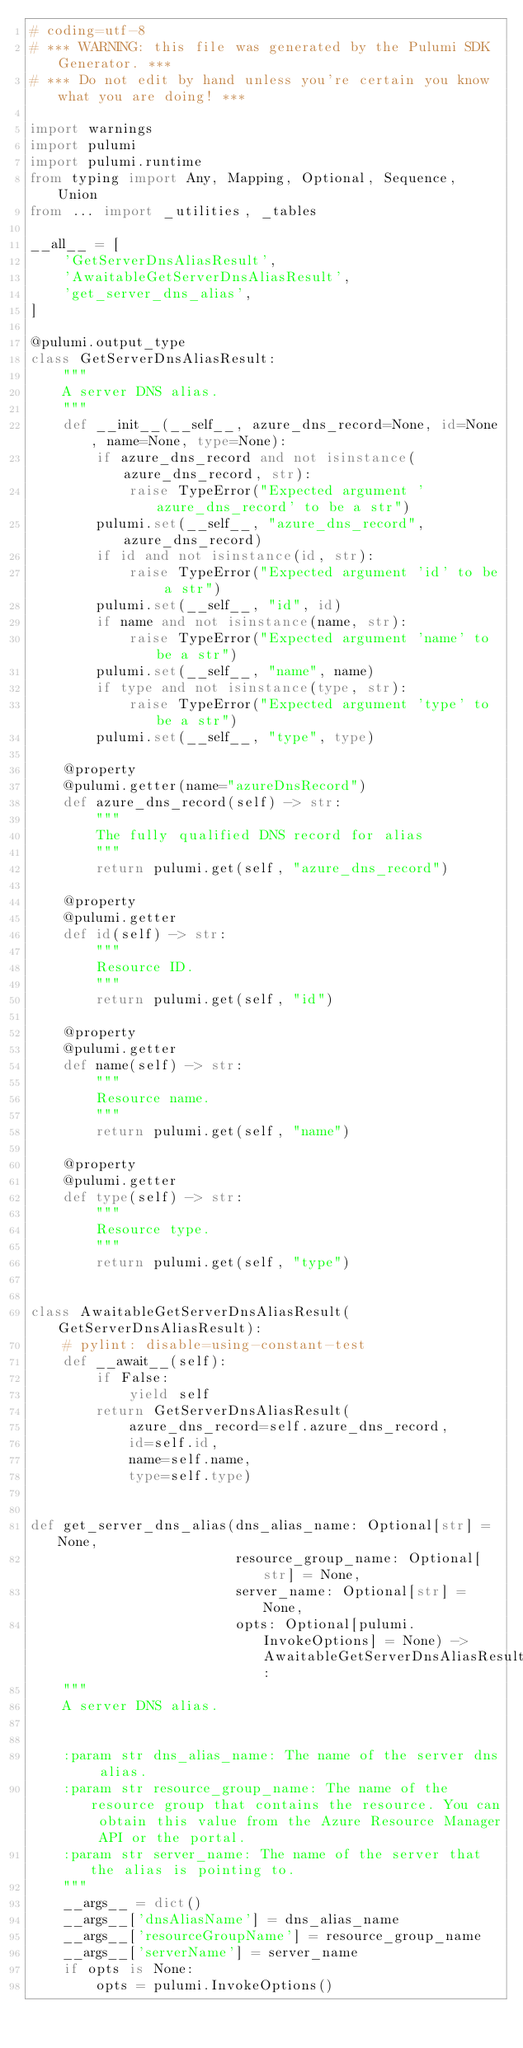Convert code to text. <code><loc_0><loc_0><loc_500><loc_500><_Python_># coding=utf-8
# *** WARNING: this file was generated by the Pulumi SDK Generator. ***
# *** Do not edit by hand unless you're certain you know what you are doing! ***

import warnings
import pulumi
import pulumi.runtime
from typing import Any, Mapping, Optional, Sequence, Union
from ... import _utilities, _tables

__all__ = [
    'GetServerDnsAliasResult',
    'AwaitableGetServerDnsAliasResult',
    'get_server_dns_alias',
]

@pulumi.output_type
class GetServerDnsAliasResult:
    """
    A server DNS alias.
    """
    def __init__(__self__, azure_dns_record=None, id=None, name=None, type=None):
        if azure_dns_record and not isinstance(azure_dns_record, str):
            raise TypeError("Expected argument 'azure_dns_record' to be a str")
        pulumi.set(__self__, "azure_dns_record", azure_dns_record)
        if id and not isinstance(id, str):
            raise TypeError("Expected argument 'id' to be a str")
        pulumi.set(__self__, "id", id)
        if name and not isinstance(name, str):
            raise TypeError("Expected argument 'name' to be a str")
        pulumi.set(__self__, "name", name)
        if type and not isinstance(type, str):
            raise TypeError("Expected argument 'type' to be a str")
        pulumi.set(__self__, "type", type)

    @property
    @pulumi.getter(name="azureDnsRecord")
    def azure_dns_record(self) -> str:
        """
        The fully qualified DNS record for alias
        """
        return pulumi.get(self, "azure_dns_record")

    @property
    @pulumi.getter
    def id(self) -> str:
        """
        Resource ID.
        """
        return pulumi.get(self, "id")

    @property
    @pulumi.getter
    def name(self) -> str:
        """
        Resource name.
        """
        return pulumi.get(self, "name")

    @property
    @pulumi.getter
    def type(self) -> str:
        """
        Resource type.
        """
        return pulumi.get(self, "type")


class AwaitableGetServerDnsAliasResult(GetServerDnsAliasResult):
    # pylint: disable=using-constant-test
    def __await__(self):
        if False:
            yield self
        return GetServerDnsAliasResult(
            azure_dns_record=self.azure_dns_record,
            id=self.id,
            name=self.name,
            type=self.type)


def get_server_dns_alias(dns_alias_name: Optional[str] = None,
                         resource_group_name: Optional[str] = None,
                         server_name: Optional[str] = None,
                         opts: Optional[pulumi.InvokeOptions] = None) -> AwaitableGetServerDnsAliasResult:
    """
    A server DNS alias.


    :param str dns_alias_name: The name of the server dns alias.
    :param str resource_group_name: The name of the resource group that contains the resource. You can obtain this value from the Azure Resource Manager API or the portal.
    :param str server_name: The name of the server that the alias is pointing to.
    """
    __args__ = dict()
    __args__['dnsAliasName'] = dns_alias_name
    __args__['resourceGroupName'] = resource_group_name
    __args__['serverName'] = server_name
    if opts is None:
        opts = pulumi.InvokeOptions()</code> 